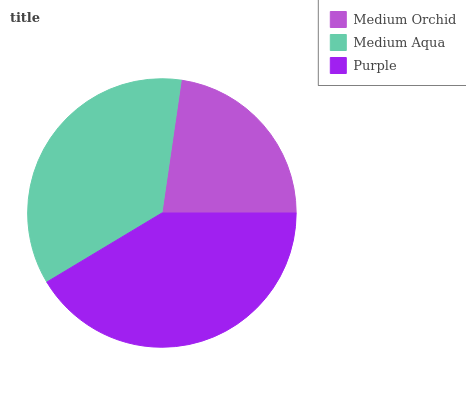Is Medium Orchid the minimum?
Answer yes or no. Yes. Is Purple the maximum?
Answer yes or no. Yes. Is Medium Aqua the minimum?
Answer yes or no. No. Is Medium Aqua the maximum?
Answer yes or no. No. Is Medium Aqua greater than Medium Orchid?
Answer yes or no. Yes. Is Medium Orchid less than Medium Aqua?
Answer yes or no. Yes. Is Medium Orchid greater than Medium Aqua?
Answer yes or no. No. Is Medium Aqua less than Medium Orchid?
Answer yes or no. No. Is Medium Aqua the high median?
Answer yes or no. Yes. Is Medium Aqua the low median?
Answer yes or no. Yes. Is Purple the high median?
Answer yes or no. No. Is Medium Orchid the low median?
Answer yes or no. No. 